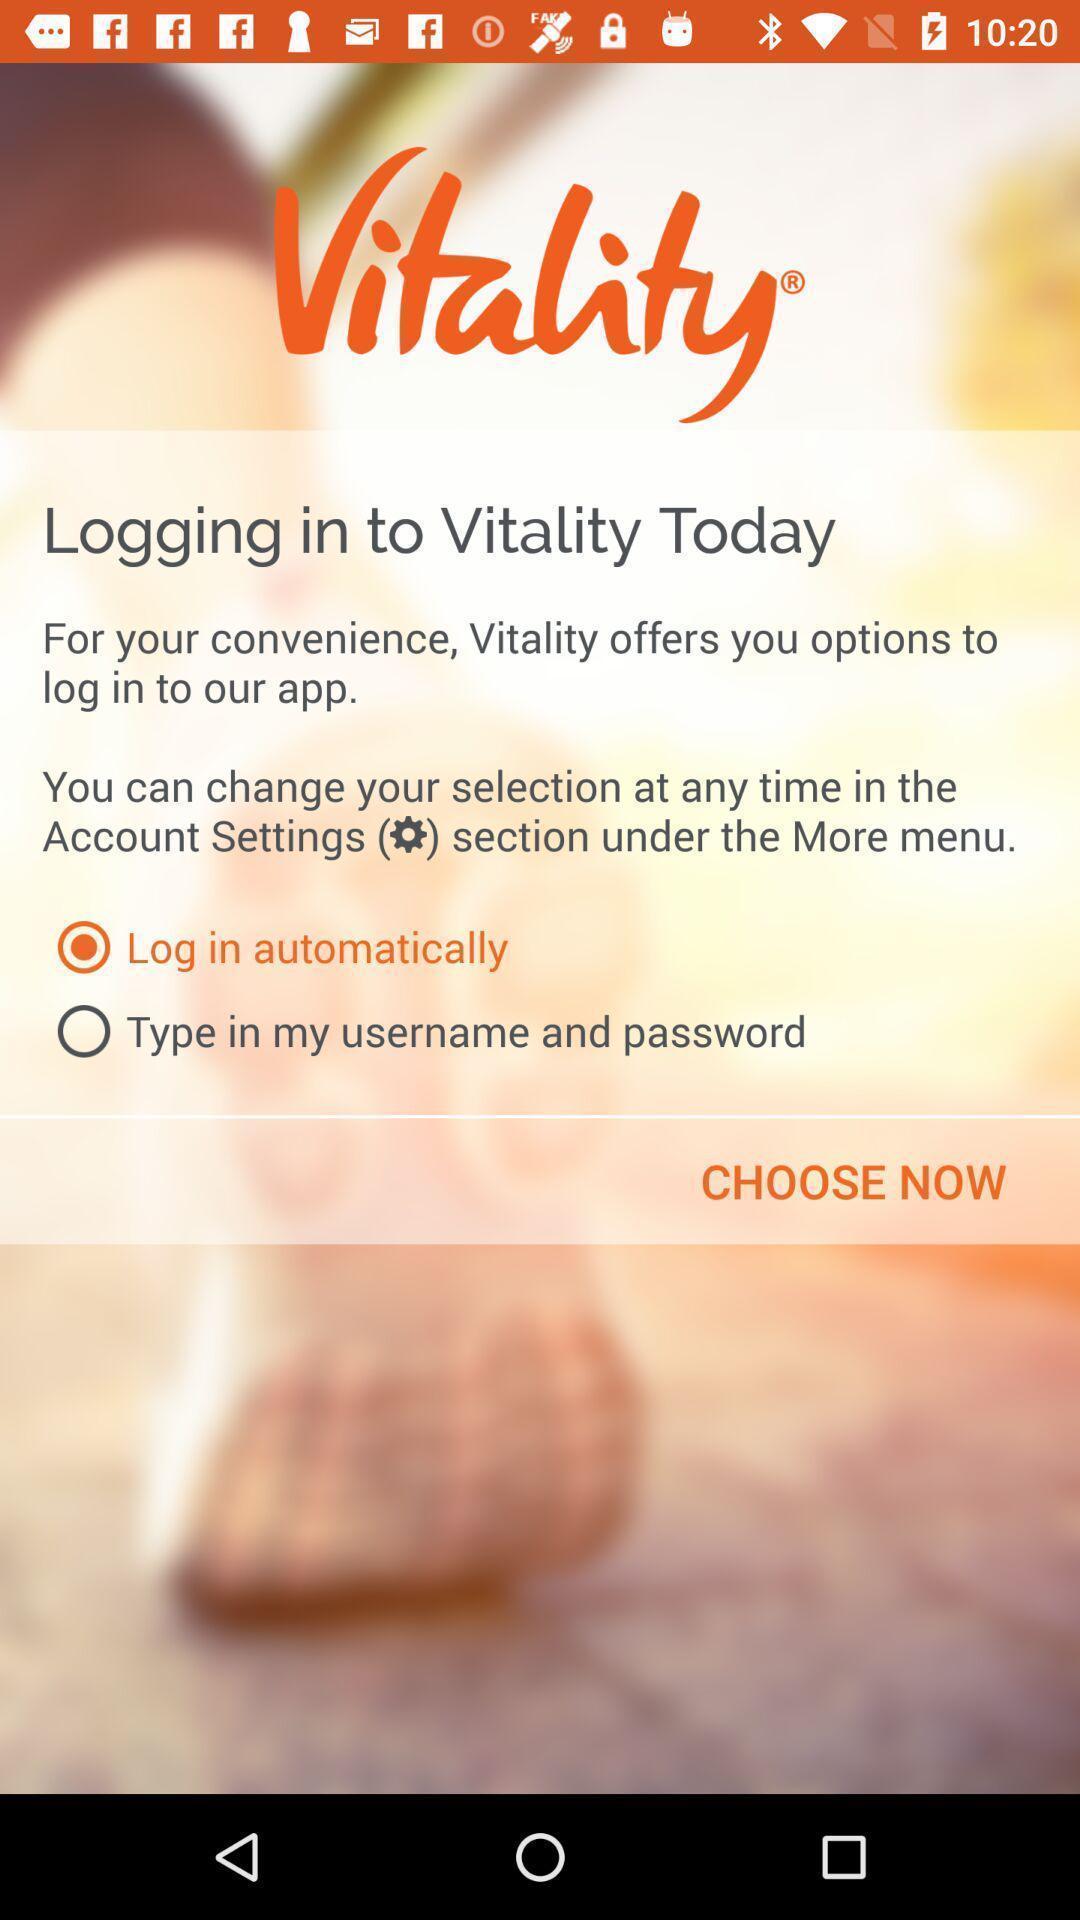Explain the elements present in this screenshot. Welcome page of profile tracking application. 